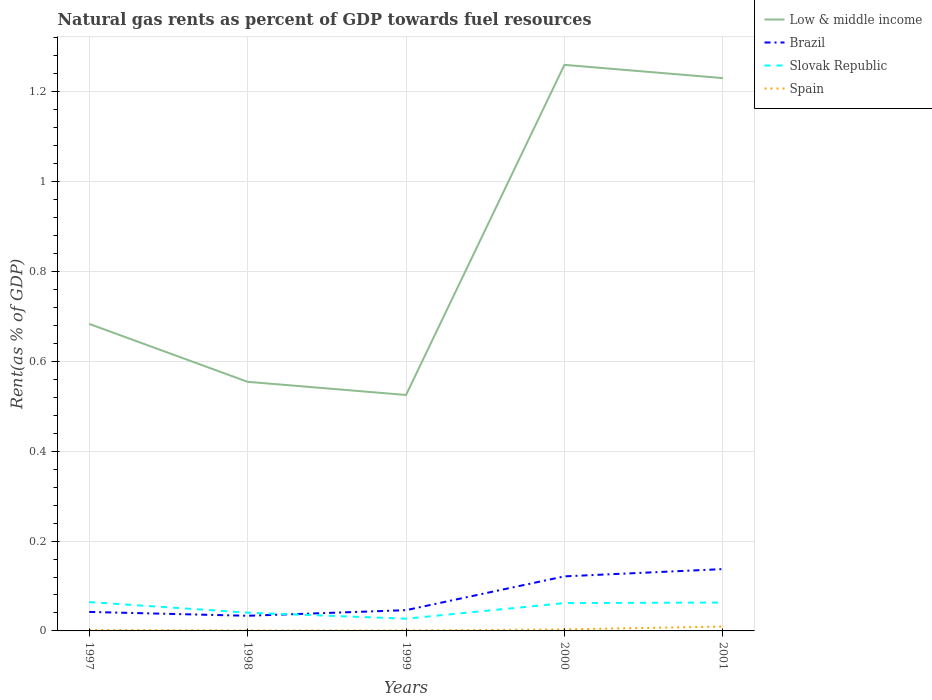How many different coloured lines are there?
Offer a terse response. 4. Across all years, what is the maximum matural gas rent in Brazil?
Give a very brief answer. 0.03. What is the total matural gas rent in Spain in the graph?
Offer a terse response. -0.01. What is the difference between the highest and the second highest matural gas rent in Low & middle income?
Your answer should be very brief. 0.73. What is the difference between two consecutive major ticks on the Y-axis?
Your answer should be very brief. 0.2. Are the values on the major ticks of Y-axis written in scientific E-notation?
Give a very brief answer. No. Where does the legend appear in the graph?
Your answer should be compact. Top right. How many legend labels are there?
Give a very brief answer. 4. How are the legend labels stacked?
Provide a succinct answer. Vertical. What is the title of the graph?
Provide a short and direct response. Natural gas rents as percent of GDP towards fuel resources. Does "Malta" appear as one of the legend labels in the graph?
Offer a terse response. No. What is the label or title of the Y-axis?
Your answer should be very brief. Rent(as % of GDP). What is the Rent(as % of GDP) in Low & middle income in 1997?
Provide a succinct answer. 0.68. What is the Rent(as % of GDP) in Brazil in 1997?
Offer a terse response. 0.04. What is the Rent(as % of GDP) in Slovak Republic in 1997?
Give a very brief answer. 0.06. What is the Rent(as % of GDP) in Spain in 1997?
Offer a terse response. 0. What is the Rent(as % of GDP) in Low & middle income in 1998?
Your answer should be compact. 0.55. What is the Rent(as % of GDP) of Brazil in 1998?
Give a very brief answer. 0.03. What is the Rent(as % of GDP) in Slovak Republic in 1998?
Ensure brevity in your answer.  0.04. What is the Rent(as % of GDP) in Spain in 1998?
Your answer should be compact. 0. What is the Rent(as % of GDP) in Low & middle income in 1999?
Give a very brief answer. 0.53. What is the Rent(as % of GDP) in Brazil in 1999?
Offer a very short reply. 0.05. What is the Rent(as % of GDP) of Slovak Republic in 1999?
Your answer should be very brief. 0.03. What is the Rent(as % of GDP) in Spain in 1999?
Offer a terse response. 0. What is the Rent(as % of GDP) of Low & middle income in 2000?
Offer a terse response. 1.26. What is the Rent(as % of GDP) in Brazil in 2000?
Make the answer very short. 0.12. What is the Rent(as % of GDP) in Slovak Republic in 2000?
Provide a short and direct response. 0.06. What is the Rent(as % of GDP) of Spain in 2000?
Provide a succinct answer. 0. What is the Rent(as % of GDP) of Low & middle income in 2001?
Your response must be concise. 1.23. What is the Rent(as % of GDP) in Brazil in 2001?
Provide a succinct answer. 0.14. What is the Rent(as % of GDP) in Slovak Republic in 2001?
Provide a succinct answer. 0.06. What is the Rent(as % of GDP) in Spain in 2001?
Your response must be concise. 0.01. Across all years, what is the maximum Rent(as % of GDP) of Low & middle income?
Offer a terse response. 1.26. Across all years, what is the maximum Rent(as % of GDP) of Brazil?
Provide a succinct answer. 0.14. Across all years, what is the maximum Rent(as % of GDP) of Slovak Republic?
Provide a short and direct response. 0.06. Across all years, what is the maximum Rent(as % of GDP) of Spain?
Keep it short and to the point. 0.01. Across all years, what is the minimum Rent(as % of GDP) of Low & middle income?
Make the answer very short. 0.53. Across all years, what is the minimum Rent(as % of GDP) of Brazil?
Give a very brief answer. 0.03. Across all years, what is the minimum Rent(as % of GDP) of Slovak Republic?
Provide a short and direct response. 0.03. Across all years, what is the minimum Rent(as % of GDP) in Spain?
Your answer should be compact. 0. What is the total Rent(as % of GDP) in Low & middle income in the graph?
Give a very brief answer. 4.25. What is the total Rent(as % of GDP) of Brazil in the graph?
Offer a terse response. 0.38. What is the total Rent(as % of GDP) in Slovak Republic in the graph?
Your answer should be very brief. 0.26. What is the total Rent(as % of GDP) in Spain in the graph?
Offer a very short reply. 0.02. What is the difference between the Rent(as % of GDP) in Low & middle income in 1997 and that in 1998?
Provide a succinct answer. 0.13. What is the difference between the Rent(as % of GDP) of Brazil in 1997 and that in 1998?
Offer a very short reply. 0.01. What is the difference between the Rent(as % of GDP) in Slovak Republic in 1997 and that in 1998?
Offer a very short reply. 0.02. What is the difference between the Rent(as % of GDP) in Spain in 1997 and that in 1998?
Offer a terse response. 0. What is the difference between the Rent(as % of GDP) of Low & middle income in 1997 and that in 1999?
Your answer should be compact. 0.16. What is the difference between the Rent(as % of GDP) of Brazil in 1997 and that in 1999?
Give a very brief answer. -0. What is the difference between the Rent(as % of GDP) of Slovak Republic in 1997 and that in 1999?
Your answer should be compact. 0.04. What is the difference between the Rent(as % of GDP) in Spain in 1997 and that in 1999?
Keep it short and to the point. 0. What is the difference between the Rent(as % of GDP) of Low & middle income in 1997 and that in 2000?
Provide a succinct answer. -0.58. What is the difference between the Rent(as % of GDP) of Brazil in 1997 and that in 2000?
Your response must be concise. -0.08. What is the difference between the Rent(as % of GDP) of Slovak Republic in 1997 and that in 2000?
Your answer should be compact. 0. What is the difference between the Rent(as % of GDP) in Spain in 1997 and that in 2000?
Give a very brief answer. -0. What is the difference between the Rent(as % of GDP) of Low & middle income in 1997 and that in 2001?
Provide a short and direct response. -0.55. What is the difference between the Rent(as % of GDP) in Brazil in 1997 and that in 2001?
Offer a terse response. -0.1. What is the difference between the Rent(as % of GDP) in Spain in 1997 and that in 2001?
Your answer should be very brief. -0.01. What is the difference between the Rent(as % of GDP) in Low & middle income in 1998 and that in 1999?
Your answer should be compact. 0.03. What is the difference between the Rent(as % of GDP) of Brazil in 1998 and that in 1999?
Offer a very short reply. -0.01. What is the difference between the Rent(as % of GDP) in Slovak Republic in 1998 and that in 1999?
Provide a succinct answer. 0.01. What is the difference between the Rent(as % of GDP) of Low & middle income in 1998 and that in 2000?
Offer a terse response. -0.71. What is the difference between the Rent(as % of GDP) in Brazil in 1998 and that in 2000?
Make the answer very short. -0.09. What is the difference between the Rent(as % of GDP) of Slovak Republic in 1998 and that in 2000?
Offer a terse response. -0.02. What is the difference between the Rent(as % of GDP) of Spain in 1998 and that in 2000?
Offer a very short reply. -0. What is the difference between the Rent(as % of GDP) of Low & middle income in 1998 and that in 2001?
Your answer should be very brief. -0.68. What is the difference between the Rent(as % of GDP) in Brazil in 1998 and that in 2001?
Keep it short and to the point. -0.1. What is the difference between the Rent(as % of GDP) of Slovak Republic in 1998 and that in 2001?
Provide a succinct answer. -0.02. What is the difference between the Rent(as % of GDP) of Spain in 1998 and that in 2001?
Your answer should be very brief. -0.01. What is the difference between the Rent(as % of GDP) of Low & middle income in 1999 and that in 2000?
Provide a short and direct response. -0.73. What is the difference between the Rent(as % of GDP) of Brazil in 1999 and that in 2000?
Make the answer very short. -0.08. What is the difference between the Rent(as % of GDP) in Slovak Republic in 1999 and that in 2000?
Keep it short and to the point. -0.03. What is the difference between the Rent(as % of GDP) in Spain in 1999 and that in 2000?
Make the answer very short. -0. What is the difference between the Rent(as % of GDP) in Low & middle income in 1999 and that in 2001?
Offer a terse response. -0.71. What is the difference between the Rent(as % of GDP) in Brazil in 1999 and that in 2001?
Ensure brevity in your answer.  -0.09. What is the difference between the Rent(as % of GDP) in Slovak Republic in 1999 and that in 2001?
Your answer should be very brief. -0.04. What is the difference between the Rent(as % of GDP) of Spain in 1999 and that in 2001?
Your response must be concise. -0.01. What is the difference between the Rent(as % of GDP) of Low & middle income in 2000 and that in 2001?
Give a very brief answer. 0.03. What is the difference between the Rent(as % of GDP) in Brazil in 2000 and that in 2001?
Provide a succinct answer. -0.02. What is the difference between the Rent(as % of GDP) in Slovak Republic in 2000 and that in 2001?
Your answer should be very brief. -0. What is the difference between the Rent(as % of GDP) in Spain in 2000 and that in 2001?
Provide a succinct answer. -0.01. What is the difference between the Rent(as % of GDP) in Low & middle income in 1997 and the Rent(as % of GDP) in Brazil in 1998?
Ensure brevity in your answer.  0.65. What is the difference between the Rent(as % of GDP) in Low & middle income in 1997 and the Rent(as % of GDP) in Slovak Republic in 1998?
Provide a short and direct response. 0.64. What is the difference between the Rent(as % of GDP) in Low & middle income in 1997 and the Rent(as % of GDP) in Spain in 1998?
Provide a short and direct response. 0.68. What is the difference between the Rent(as % of GDP) of Brazil in 1997 and the Rent(as % of GDP) of Slovak Republic in 1998?
Your answer should be very brief. 0. What is the difference between the Rent(as % of GDP) in Brazil in 1997 and the Rent(as % of GDP) in Spain in 1998?
Make the answer very short. 0.04. What is the difference between the Rent(as % of GDP) in Slovak Republic in 1997 and the Rent(as % of GDP) in Spain in 1998?
Offer a very short reply. 0.06. What is the difference between the Rent(as % of GDP) of Low & middle income in 1997 and the Rent(as % of GDP) of Brazil in 1999?
Make the answer very short. 0.64. What is the difference between the Rent(as % of GDP) in Low & middle income in 1997 and the Rent(as % of GDP) in Slovak Republic in 1999?
Offer a very short reply. 0.66. What is the difference between the Rent(as % of GDP) in Low & middle income in 1997 and the Rent(as % of GDP) in Spain in 1999?
Provide a short and direct response. 0.68. What is the difference between the Rent(as % of GDP) in Brazil in 1997 and the Rent(as % of GDP) in Slovak Republic in 1999?
Give a very brief answer. 0.02. What is the difference between the Rent(as % of GDP) in Brazil in 1997 and the Rent(as % of GDP) in Spain in 1999?
Your answer should be compact. 0.04. What is the difference between the Rent(as % of GDP) of Slovak Republic in 1997 and the Rent(as % of GDP) of Spain in 1999?
Make the answer very short. 0.06. What is the difference between the Rent(as % of GDP) in Low & middle income in 1997 and the Rent(as % of GDP) in Brazil in 2000?
Provide a short and direct response. 0.56. What is the difference between the Rent(as % of GDP) in Low & middle income in 1997 and the Rent(as % of GDP) in Slovak Republic in 2000?
Your response must be concise. 0.62. What is the difference between the Rent(as % of GDP) of Low & middle income in 1997 and the Rent(as % of GDP) of Spain in 2000?
Give a very brief answer. 0.68. What is the difference between the Rent(as % of GDP) in Brazil in 1997 and the Rent(as % of GDP) in Slovak Republic in 2000?
Offer a very short reply. -0.02. What is the difference between the Rent(as % of GDP) in Brazil in 1997 and the Rent(as % of GDP) in Spain in 2000?
Your answer should be very brief. 0.04. What is the difference between the Rent(as % of GDP) in Slovak Republic in 1997 and the Rent(as % of GDP) in Spain in 2000?
Your answer should be very brief. 0.06. What is the difference between the Rent(as % of GDP) in Low & middle income in 1997 and the Rent(as % of GDP) in Brazil in 2001?
Your response must be concise. 0.55. What is the difference between the Rent(as % of GDP) in Low & middle income in 1997 and the Rent(as % of GDP) in Slovak Republic in 2001?
Give a very brief answer. 0.62. What is the difference between the Rent(as % of GDP) of Low & middle income in 1997 and the Rent(as % of GDP) of Spain in 2001?
Give a very brief answer. 0.67. What is the difference between the Rent(as % of GDP) in Brazil in 1997 and the Rent(as % of GDP) in Slovak Republic in 2001?
Keep it short and to the point. -0.02. What is the difference between the Rent(as % of GDP) of Brazil in 1997 and the Rent(as % of GDP) of Spain in 2001?
Offer a very short reply. 0.03. What is the difference between the Rent(as % of GDP) of Slovak Republic in 1997 and the Rent(as % of GDP) of Spain in 2001?
Offer a very short reply. 0.05. What is the difference between the Rent(as % of GDP) in Low & middle income in 1998 and the Rent(as % of GDP) in Brazil in 1999?
Your answer should be compact. 0.51. What is the difference between the Rent(as % of GDP) of Low & middle income in 1998 and the Rent(as % of GDP) of Slovak Republic in 1999?
Make the answer very short. 0.53. What is the difference between the Rent(as % of GDP) of Low & middle income in 1998 and the Rent(as % of GDP) of Spain in 1999?
Offer a very short reply. 0.55. What is the difference between the Rent(as % of GDP) in Brazil in 1998 and the Rent(as % of GDP) in Slovak Republic in 1999?
Provide a short and direct response. 0.01. What is the difference between the Rent(as % of GDP) of Brazil in 1998 and the Rent(as % of GDP) of Spain in 1999?
Ensure brevity in your answer.  0.03. What is the difference between the Rent(as % of GDP) of Slovak Republic in 1998 and the Rent(as % of GDP) of Spain in 1999?
Ensure brevity in your answer.  0.04. What is the difference between the Rent(as % of GDP) in Low & middle income in 1998 and the Rent(as % of GDP) in Brazil in 2000?
Your answer should be very brief. 0.43. What is the difference between the Rent(as % of GDP) in Low & middle income in 1998 and the Rent(as % of GDP) in Slovak Republic in 2000?
Provide a succinct answer. 0.49. What is the difference between the Rent(as % of GDP) of Low & middle income in 1998 and the Rent(as % of GDP) of Spain in 2000?
Make the answer very short. 0.55. What is the difference between the Rent(as % of GDP) in Brazil in 1998 and the Rent(as % of GDP) in Slovak Republic in 2000?
Provide a succinct answer. -0.03. What is the difference between the Rent(as % of GDP) in Brazil in 1998 and the Rent(as % of GDP) in Spain in 2000?
Ensure brevity in your answer.  0.03. What is the difference between the Rent(as % of GDP) of Slovak Republic in 1998 and the Rent(as % of GDP) of Spain in 2000?
Make the answer very short. 0.04. What is the difference between the Rent(as % of GDP) in Low & middle income in 1998 and the Rent(as % of GDP) in Brazil in 2001?
Keep it short and to the point. 0.42. What is the difference between the Rent(as % of GDP) in Low & middle income in 1998 and the Rent(as % of GDP) in Slovak Republic in 2001?
Offer a terse response. 0.49. What is the difference between the Rent(as % of GDP) of Low & middle income in 1998 and the Rent(as % of GDP) of Spain in 2001?
Offer a terse response. 0.54. What is the difference between the Rent(as % of GDP) of Brazil in 1998 and the Rent(as % of GDP) of Slovak Republic in 2001?
Ensure brevity in your answer.  -0.03. What is the difference between the Rent(as % of GDP) in Brazil in 1998 and the Rent(as % of GDP) in Spain in 2001?
Your response must be concise. 0.02. What is the difference between the Rent(as % of GDP) of Slovak Republic in 1998 and the Rent(as % of GDP) of Spain in 2001?
Your answer should be very brief. 0.03. What is the difference between the Rent(as % of GDP) of Low & middle income in 1999 and the Rent(as % of GDP) of Brazil in 2000?
Offer a terse response. 0.4. What is the difference between the Rent(as % of GDP) of Low & middle income in 1999 and the Rent(as % of GDP) of Slovak Republic in 2000?
Ensure brevity in your answer.  0.46. What is the difference between the Rent(as % of GDP) in Low & middle income in 1999 and the Rent(as % of GDP) in Spain in 2000?
Provide a succinct answer. 0.52. What is the difference between the Rent(as % of GDP) in Brazil in 1999 and the Rent(as % of GDP) in Slovak Republic in 2000?
Keep it short and to the point. -0.02. What is the difference between the Rent(as % of GDP) of Brazil in 1999 and the Rent(as % of GDP) of Spain in 2000?
Offer a terse response. 0.04. What is the difference between the Rent(as % of GDP) of Slovak Republic in 1999 and the Rent(as % of GDP) of Spain in 2000?
Offer a very short reply. 0.02. What is the difference between the Rent(as % of GDP) in Low & middle income in 1999 and the Rent(as % of GDP) in Brazil in 2001?
Give a very brief answer. 0.39. What is the difference between the Rent(as % of GDP) in Low & middle income in 1999 and the Rent(as % of GDP) in Slovak Republic in 2001?
Make the answer very short. 0.46. What is the difference between the Rent(as % of GDP) in Low & middle income in 1999 and the Rent(as % of GDP) in Spain in 2001?
Keep it short and to the point. 0.52. What is the difference between the Rent(as % of GDP) in Brazil in 1999 and the Rent(as % of GDP) in Slovak Republic in 2001?
Your answer should be very brief. -0.02. What is the difference between the Rent(as % of GDP) in Brazil in 1999 and the Rent(as % of GDP) in Spain in 2001?
Make the answer very short. 0.04. What is the difference between the Rent(as % of GDP) of Slovak Republic in 1999 and the Rent(as % of GDP) of Spain in 2001?
Offer a terse response. 0.02. What is the difference between the Rent(as % of GDP) in Low & middle income in 2000 and the Rent(as % of GDP) in Brazil in 2001?
Make the answer very short. 1.12. What is the difference between the Rent(as % of GDP) in Low & middle income in 2000 and the Rent(as % of GDP) in Slovak Republic in 2001?
Your response must be concise. 1.2. What is the difference between the Rent(as % of GDP) in Low & middle income in 2000 and the Rent(as % of GDP) in Spain in 2001?
Provide a short and direct response. 1.25. What is the difference between the Rent(as % of GDP) of Brazil in 2000 and the Rent(as % of GDP) of Slovak Republic in 2001?
Ensure brevity in your answer.  0.06. What is the difference between the Rent(as % of GDP) in Brazil in 2000 and the Rent(as % of GDP) in Spain in 2001?
Offer a terse response. 0.11. What is the difference between the Rent(as % of GDP) in Slovak Republic in 2000 and the Rent(as % of GDP) in Spain in 2001?
Your answer should be compact. 0.05. What is the average Rent(as % of GDP) in Low & middle income per year?
Make the answer very short. 0.85. What is the average Rent(as % of GDP) in Brazil per year?
Provide a short and direct response. 0.08. What is the average Rent(as % of GDP) of Slovak Republic per year?
Give a very brief answer. 0.05. What is the average Rent(as % of GDP) of Spain per year?
Provide a short and direct response. 0. In the year 1997, what is the difference between the Rent(as % of GDP) of Low & middle income and Rent(as % of GDP) of Brazil?
Your response must be concise. 0.64. In the year 1997, what is the difference between the Rent(as % of GDP) in Low & middle income and Rent(as % of GDP) in Slovak Republic?
Offer a very short reply. 0.62. In the year 1997, what is the difference between the Rent(as % of GDP) in Low & middle income and Rent(as % of GDP) in Spain?
Ensure brevity in your answer.  0.68. In the year 1997, what is the difference between the Rent(as % of GDP) in Brazil and Rent(as % of GDP) in Slovak Republic?
Provide a short and direct response. -0.02. In the year 1997, what is the difference between the Rent(as % of GDP) of Brazil and Rent(as % of GDP) of Spain?
Your answer should be very brief. 0.04. In the year 1997, what is the difference between the Rent(as % of GDP) of Slovak Republic and Rent(as % of GDP) of Spain?
Give a very brief answer. 0.06. In the year 1998, what is the difference between the Rent(as % of GDP) of Low & middle income and Rent(as % of GDP) of Brazil?
Keep it short and to the point. 0.52. In the year 1998, what is the difference between the Rent(as % of GDP) of Low & middle income and Rent(as % of GDP) of Slovak Republic?
Offer a terse response. 0.51. In the year 1998, what is the difference between the Rent(as % of GDP) of Low & middle income and Rent(as % of GDP) of Spain?
Make the answer very short. 0.55. In the year 1998, what is the difference between the Rent(as % of GDP) in Brazil and Rent(as % of GDP) in Slovak Republic?
Your response must be concise. -0.01. In the year 1998, what is the difference between the Rent(as % of GDP) in Brazil and Rent(as % of GDP) in Spain?
Ensure brevity in your answer.  0.03. In the year 1998, what is the difference between the Rent(as % of GDP) of Slovak Republic and Rent(as % of GDP) of Spain?
Make the answer very short. 0.04. In the year 1999, what is the difference between the Rent(as % of GDP) in Low & middle income and Rent(as % of GDP) in Brazil?
Provide a succinct answer. 0.48. In the year 1999, what is the difference between the Rent(as % of GDP) of Low & middle income and Rent(as % of GDP) of Slovak Republic?
Your answer should be very brief. 0.5. In the year 1999, what is the difference between the Rent(as % of GDP) in Low & middle income and Rent(as % of GDP) in Spain?
Offer a very short reply. 0.52. In the year 1999, what is the difference between the Rent(as % of GDP) of Brazil and Rent(as % of GDP) of Slovak Republic?
Provide a short and direct response. 0.02. In the year 1999, what is the difference between the Rent(as % of GDP) in Brazil and Rent(as % of GDP) in Spain?
Ensure brevity in your answer.  0.05. In the year 1999, what is the difference between the Rent(as % of GDP) of Slovak Republic and Rent(as % of GDP) of Spain?
Provide a short and direct response. 0.03. In the year 2000, what is the difference between the Rent(as % of GDP) of Low & middle income and Rent(as % of GDP) of Brazil?
Provide a short and direct response. 1.14. In the year 2000, what is the difference between the Rent(as % of GDP) of Low & middle income and Rent(as % of GDP) of Slovak Republic?
Your answer should be compact. 1.2. In the year 2000, what is the difference between the Rent(as % of GDP) of Low & middle income and Rent(as % of GDP) of Spain?
Provide a short and direct response. 1.26. In the year 2000, what is the difference between the Rent(as % of GDP) of Brazil and Rent(as % of GDP) of Slovak Republic?
Keep it short and to the point. 0.06. In the year 2000, what is the difference between the Rent(as % of GDP) in Brazil and Rent(as % of GDP) in Spain?
Give a very brief answer. 0.12. In the year 2000, what is the difference between the Rent(as % of GDP) in Slovak Republic and Rent(as % of GDP) in Spain?
Your answer should be compact. 0.06. In the year 2001, what is the difference between the Rent(as % of GDP) in Low & middle income and Rent(as % of GDP) in Brazil?
Your answer should be very brief. 1.09. In the year 2001, what is the difference between the Rent(as % of GDP) of Low & middle income and Rent(as % of GDP) of Slovak Republic?
Give a very brief answer. 1.17. In the year 2001, what is the difference between the Rent(as % of GDP) in Low & middle income and Rent(as % of GDP) in Spain?
Make the answer very short. 1.22. In the year 2001, what is the difference between the Rent(as % of GDP) of Brazil and Rent(as % of GDP) of Slovak Republic?
Give a very brief answer. 0.07. In the year 2001, what is the difference between the Rent(as % of GDP) in Brazil and Rent(as % of GDP) in Spain?
Provide a succinct answer. 0.13. In the year 2001, what is the difference between the Rent(as % of GDP) of Slovak Republic and Rent(as % of GDP) of Spain?
Offer a very short reply. 0.05. What is the ratio of the Rent(as % of GDP) in Low & middle income in 1997 to that in 1998?
Provide a short and direct response. 1.23. What is the ratio of the Rent(as % of GDP) in Brazil in 1997 to that in 1998?
Give a very brief answer. 1.25. What is the ratio of the Rent(as % of GDP) in Slovak Republic in 1997 to that in 1998?
Keep it short and to the point. 1.58. What is the ratio of the Rent(as % of GDP) of Spain in 1997 to that in 1998?
Your response must be concise. 2.2. What is the ratio of the Rent(as % of GDP) of Low & middle income in 1997 to that in 1999?
Your answer should be very brief. 1.3. What is the ratio of the Rent(as % of GDP) of Brazil in 1997 to that in 1999?
Provide a short and direct response. 0.92. What is the ratio of the Rent(as % of GDP) of Slovak Republic in 1997 to that in 1999?
Keep it short and to the point. 2.36. What is the ratio of the Rent(as % of GDP) of Spain in 1997 to that in 1999?
Your answer should be very brief. 2.12. What is the ratio of the Rent(as % of GDP) in Low & middle income in 1997 to that in 2000?
Give a very brief answer. 0.54. What is the ratio of the Rent(as % of GDP) in Brazil in 1997 to that in 2000?
Ensure brevity in your answer.  0.35. What is the ratio of the Rent(as % of GDP) in Slovak Republic in 1997 to that in 2000?
Keep it short and to the point. 1.04. What is the ratio of the Rent(as % of GDP) in Spain in 1997 to that in 2000?
Keep it short and to the point. 0.65. What is the ratio of the Rent(as % of GDP) in Low & middle income in 1997 to that in 2001?
Your answer should be compact. 0.56. What is the ratio of the Rent(as % of GDP) in Brazil in 1997 to that in 2001?
Offer a very short reply. 0.31. What is the ratio of the Rent(as % of GDP) in Slovak Republic in 1997 to that in 2001?
Make the answer very short. 1.02. What is the ratio of the Rent(as % of GDP) in Spain in 1997 to that in 2001?
Offer a very short reply. 0.23. What is the ratio of the Rent(as % of GDP) in Low & middle income in 1998 to that in 1999?
Offer a very short reply. 1.06. What is the ratio of the Rent(as % of GDP) in Brazil in 1998 to that in 1999?
Your response must be concise. 0.73. What is the ratio of the Rent(as % of GDP) in Slovak Republic in 1998 to that in 1999?
Offer a very short reply. 1.49. What is the ratio of the Rent(as % of GDP) in Spain in 1998 to that in 1999?
Provide a short and direct response. 0.96. What is the ratio of the Rent(as % of GDP) of Low & middle income in 1998 to that in 2000?
Make the answer very short. 0.44. What is the ratio of the Rent(as % of GDP) in Brazil in 1998 to that in 2000?
Keep it short and to the point. 0.28. What is the ratio of the Rent(as % of GDP) of Slovak Republic in 1998 to that in 2000?
Give a very brief answer. 0.66. What is the ratio of the Rent(as % of GDP) of Spain in 1998 to that in 2000?
Offer a very short reply. 0.3. What is the ratio of the Rent(as % of GDP) of Low & middle income in 1998 to that in 2001?
Your response must be concise. 0.45. What is the ratio of the Rent(as % of GDP) of Brazil in 1998 to that in 2001?
Provide a short and direct response. 0.24. What is the ratio of the Rent(as % of GDP) in Slovak Republic in 1998 to that in 2001?
Offer a terse response. 0.64. What is the ratio of the Rent(as % of GDP) of Spain in 1998 to that in 2001?
Provide a short and direct response. 0.1. What is the ratio of the Rent(as % of GDP) of Low & middle income in 1999 to that in 2000?
Provide a succinct answer. 0.42. What is the ratio of the Rent(as % of GDP) in Brazil in 1999 to that in 2000?
Provide a short and direct response. 0.38. What is the ratio of the Rent(as % of GDP) in Slovak Republic in 1999 to that in 2000?
Offer a very short reply. 0.44. What is the ratio of the Rent(as % of GDP) in Spain in 1999 to that in 2000?
Your answer should be compact. 0.31. What is the ratio of the Rent(as % of GDP) in Low & middle income in 1999 to that in 2001?
Your response must be concise. 0.43. What is the ratio of the Rent(as % of GDP) in Brazil in 1999 to that in 2001?
Your response must be concise. 0.34. What is the ratio of the Rent(as % of GDP) in Slovak Republic in 1999 to that in 2001?
Offer a terse response. 0.43. What is the ratio of the Rent(as % of GDP) in Spain in 1999 to that in 2001?
Your answer should be compact. 0.11. What is the ratio of the Rent(as % of GDP) in Low & middle income in 2000 to that in 2001?
Give a very brief answer. 1.02. What is the ratio of the Rent(as % of GDP) of Brazil in 2000 to that in 2001?
Your answer should be very brief. 0.88. What is the ratio of the Rent(as % of GDP) in Slovak Republic in 2000 to that in 2001?
Your response must be concise. 0.98. What is the ratio of the Rent(as % of GDP) in Spain in 2000 to that in 2001?
Your response must be concise. 0.35. What is the difference between the highest and the second highest Rent(as % of GDP) of Low & middle income?
Provide a short and direct response. 0.03. What is the difference between the highest and the second highest Rent(as % of GDP) of Brazil?
Make the answer very short. 0.02. What is the difference between the highest and the second highest Rent(as % of GDP) in Slovak Republic?
Provide a succinct answer. 0. What is the difference between the highest and the second highest Rent(as % of GDP) of Spain?
Your answer should be very brief. 0.01. What is the difference between the highest and the lowest Rent(as % of GDP) in Low & middle income?
Your response must be concise. 0.73. What is the difference between the highest and the lowest Rent(as % of GDP) of Brazil?
Keep it short and to the point. 0.1. What is the difference between the highest and the lowest Rent(as % of GDP) of Slovak Republic?
Your answer should be very brief. 0.04. What is the difference between the highest and the lowest Rent(as % of GDP) in Spain?
Give a very brief answer. 0.01. 